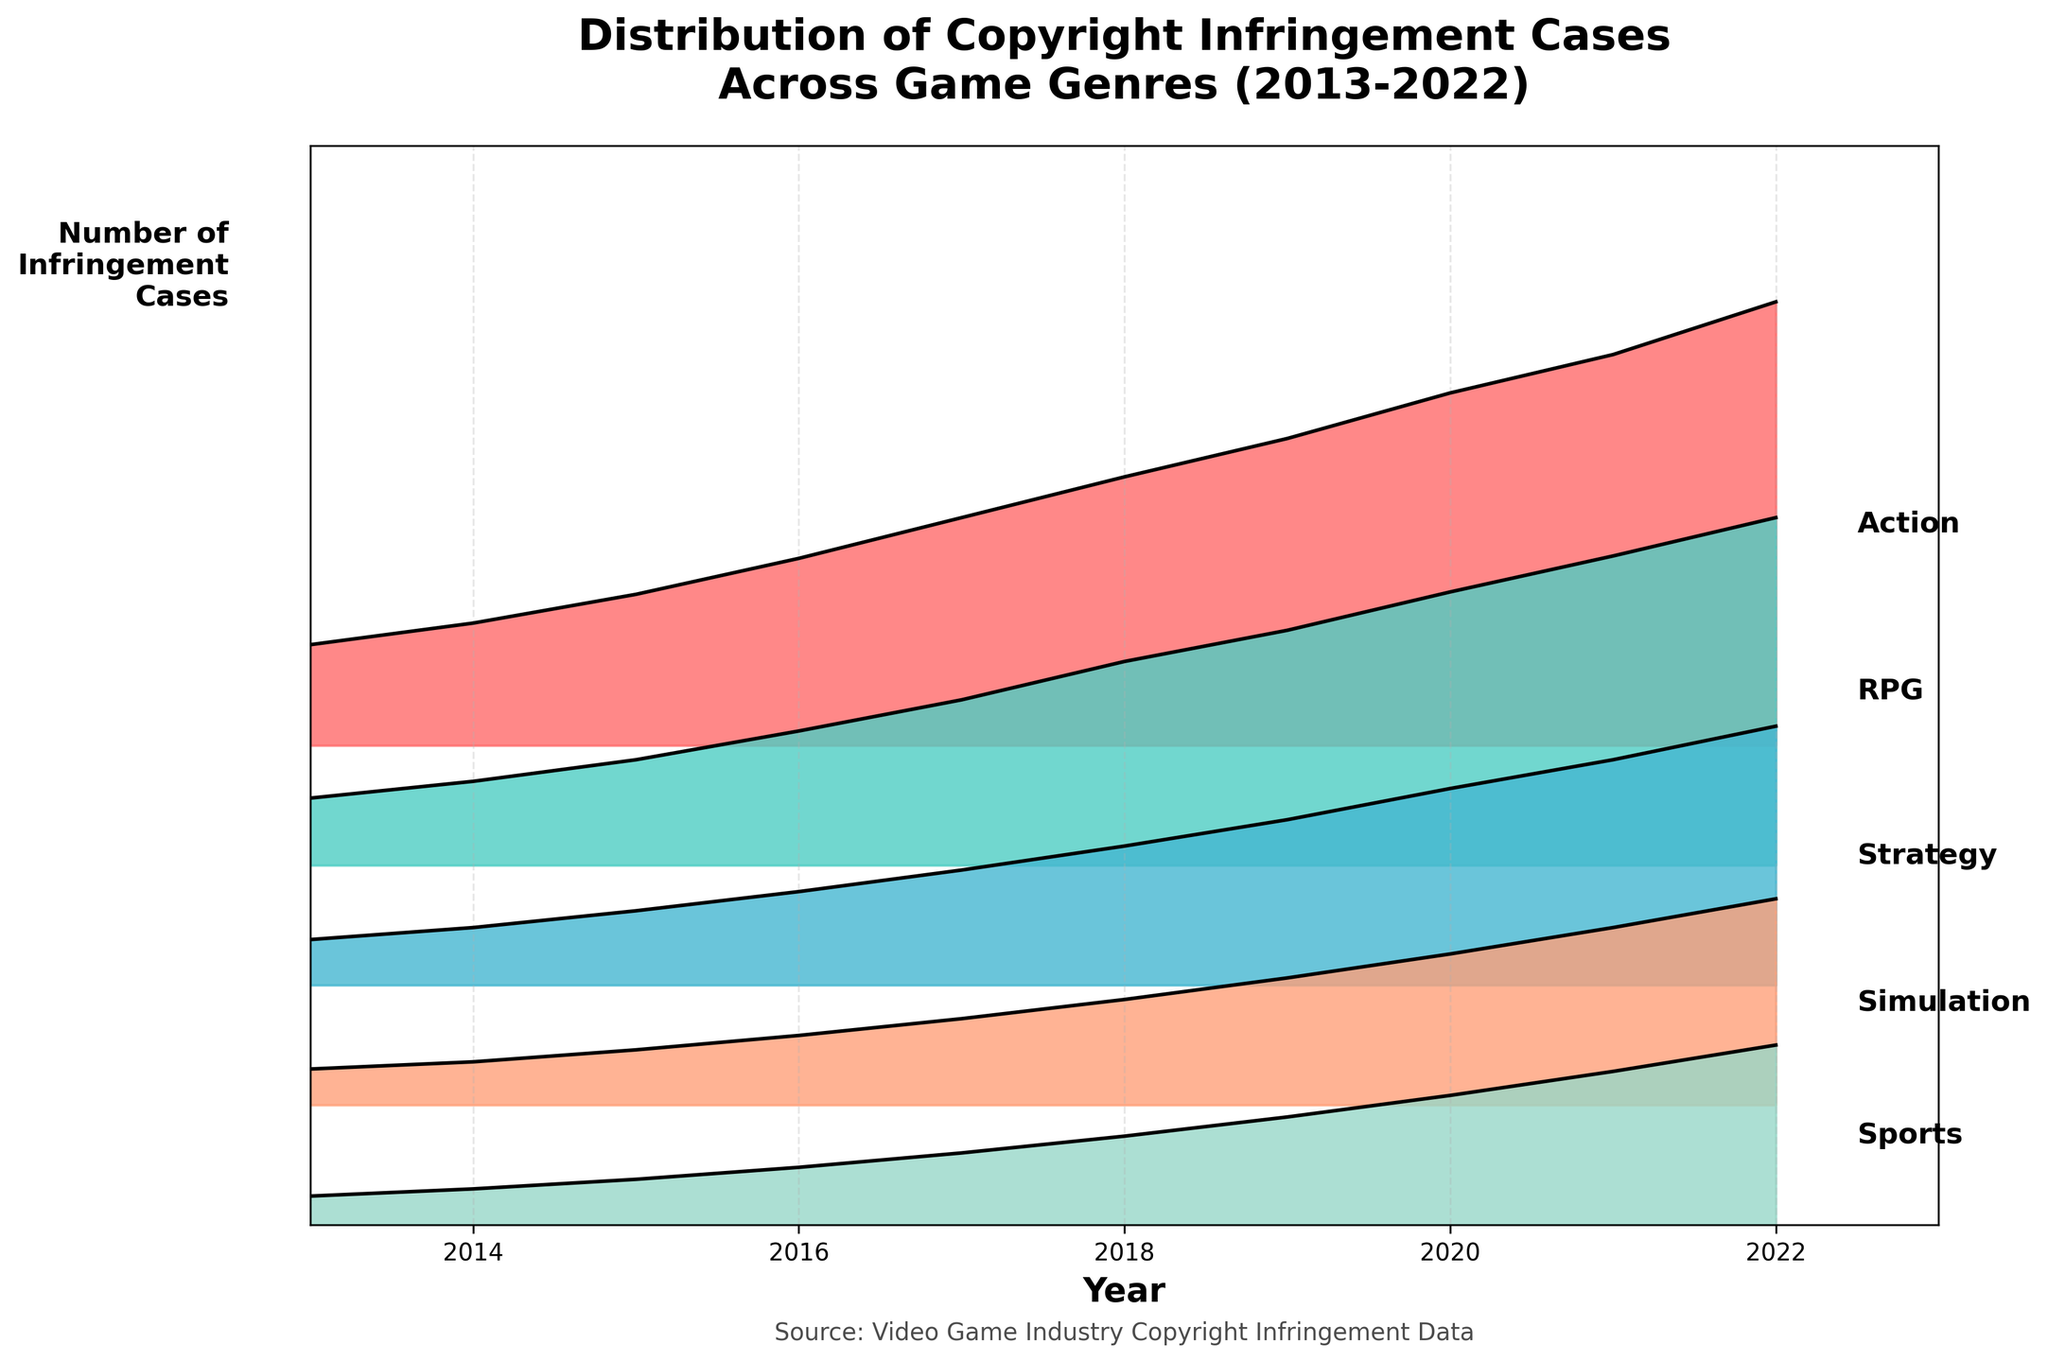What is the title of the plot? The title of the plot is displayed prominently at the top of the figure, which provides a summary of what the plot is depicting.
Answer: Distribution of Copyright Infringement Cases Across Game Genres (2013-2022) Which genre had the highest number of infringement cases in 2022? By examining the right side of the plot in 2022, the genre with the highest peak will indicate the highest number of cases. The Action genre shows the highest curve in 2022.
Answer: Action How many distinct genres are displayed in the plot? The plot has labels for each genre placed on the right side. By counting these labels, we can determine the number of distinct genres.
Answer: 5 Did any genre see a decline in infringement cases over the years? To answer this, observe the trend for each genre across the years (left to right). If the curve declines over time for any genre, then a decline is noted. None of the curves decline; they all rise gradually.
Answer: No Between Action and Simulation genres, which one saw a faster increase in infringement cases from 2013 to 2022? By comparing the slopes of the curves for Action and Simulation genres, we see that the Action curve is steeper, indicating a faster increase.
Answer: Action What was the total number of infringement cases reported for RPG and Sports genres combined in 2022? Adding the values at the peaks of the RPG and Sports genre curves in 2022, RPG has 145 and Sports has 75. Therefore, 145 + 75 = 220.
Answer: 220 Which genre had the lowest number of infringement cases in 2013? By looking at the left side of the figure for the year 2013, the genre with the lowest starting point will indicate the fewest cases. Sports shows the lowest point in 2013.
Answer: Sports By how much did the infringement cases for the Strategy genre increase between 2015 and 2018? Finding the values at 2015 and 2018 for the Strategy genre: 31 cases in 2015 and 58 cases in 2018. The increase is 58 - 31 = 27 cases.
Answer: 27 What is the average number of infringement cases for the Action genre across all years displayed? Summing up the infringement cases for the Action genre from 2013 to 2022 and dividing by the number of years: (42 + 51 + 63 + 78 + 95 + 112 + 128 + 147 + 163 + 185) / 10 = 106.4.
Answer: 106.4 Which genre experienced the most consistent yearly increase in infringement cases? Observing the smoothness and uniformity of the rise in curves for each genre, the Simulation genre shows a consistent, steady increase without sudden spikes.
Answer: Simulation 